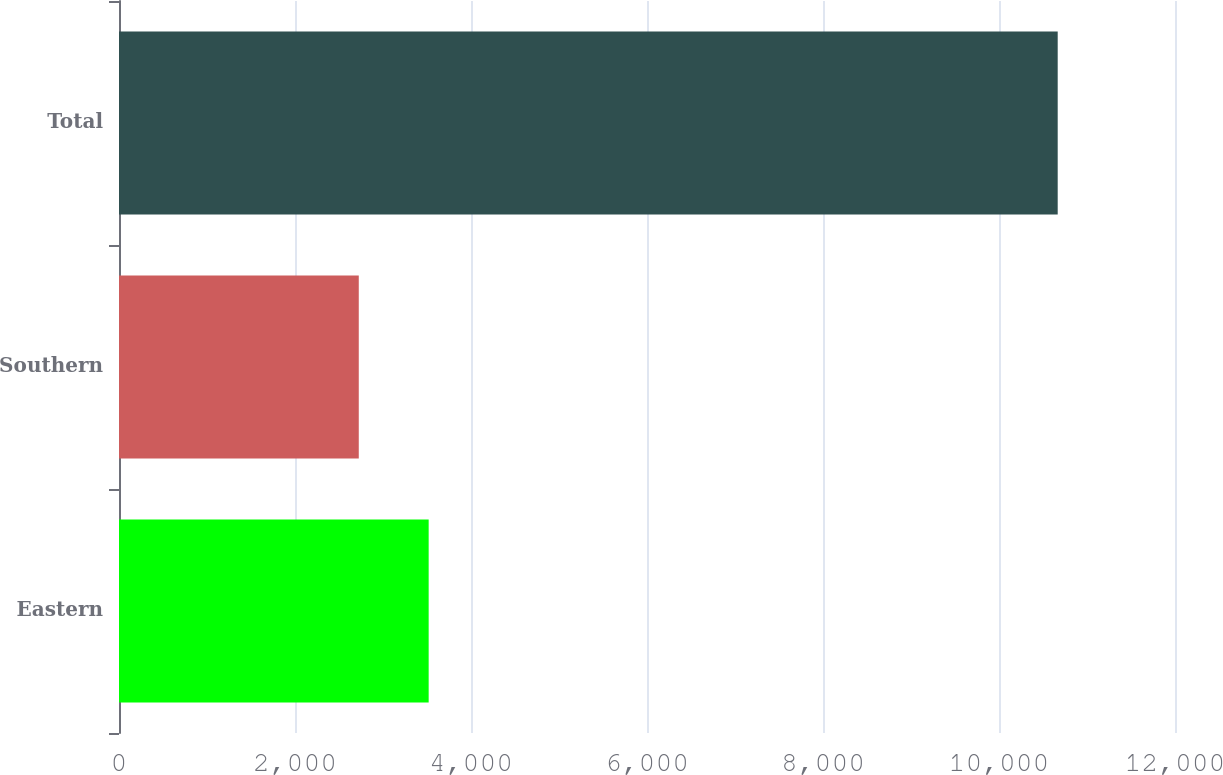Convert chart. <chart><loc_0><loc_0><loc_500><loc_500><bar_chart><fcel>Eastern<fcel>Southern<fcel>Total<nl><fcel>3518.94<fcel>2724.7<fcel>10667.1<nl></chart> 